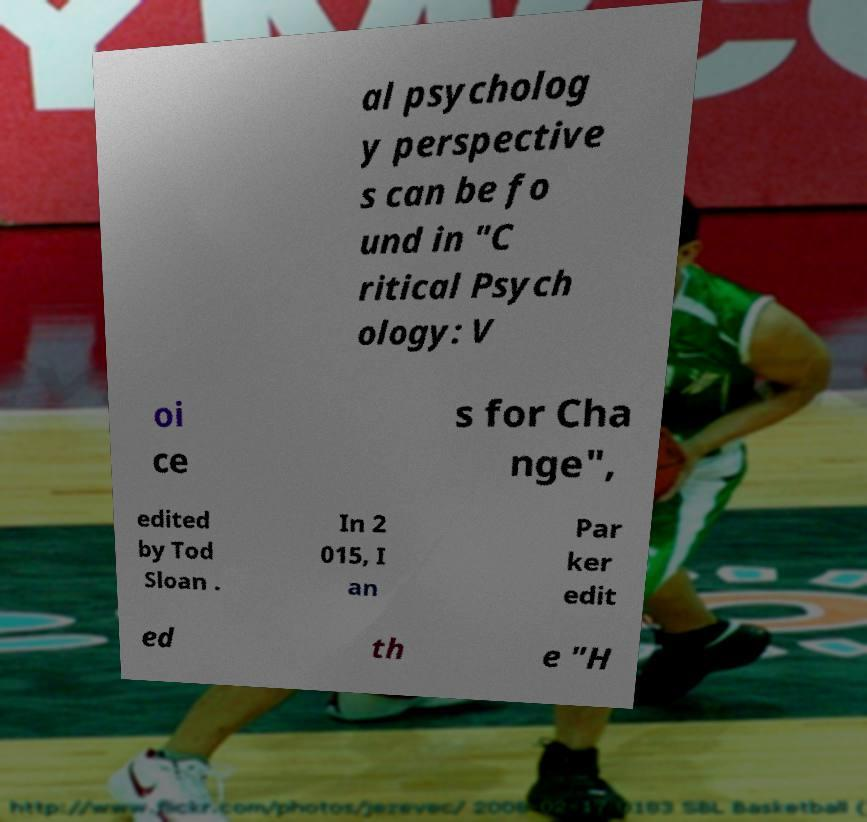Can you read and provide the text displayed in the image?This photo seems to have some interesting text. Can you extract and type it out for me? al psycholog y perspective s can be fo und in "C ritical Psych ology: V oi ce s for Cha nge", edited by Tod Sloan . In 2 015, I an Par ker edit ed th e "H 